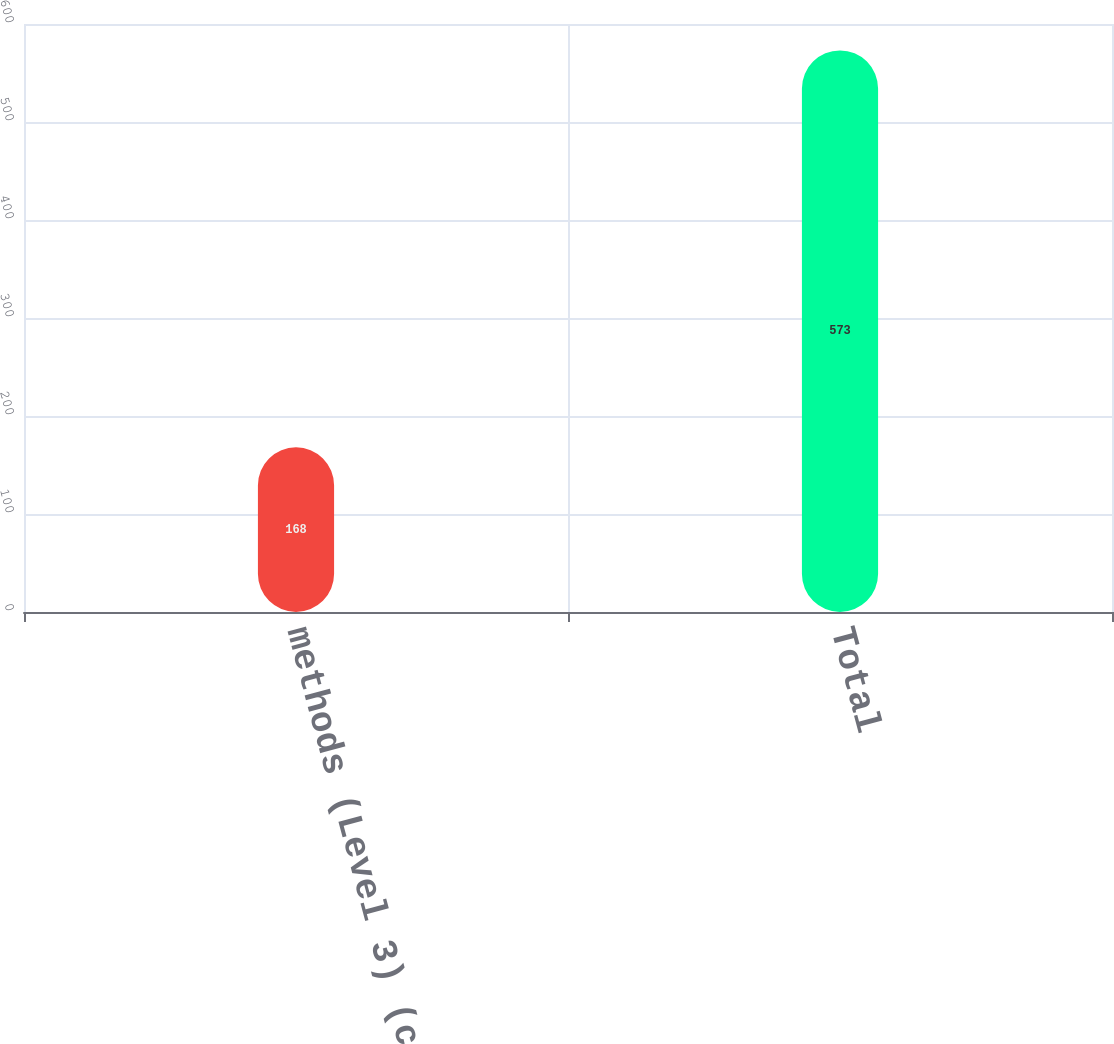<chart> <loc_0><loc_0><loc_500><loc_500><bar_chart><fcel>methods (Level 3) (c)<fcel>Total<nl><fcel>168<fcel>573<nl></chart> 